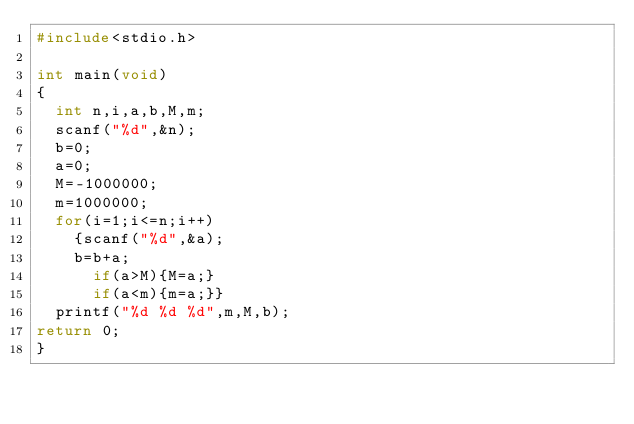<code> <loc_0><loc_0><loc_500><loc_500><_C_>#include<stdio.h>

int main(void)
{
	int n,i,a,b,M,m;
	scanf("%d",&n);
	b=0;
	a=0;
	M=-1000000;
	m=1000000;
	for(i=1;i<=n;i++)
		{scanf("%d",&a);
		b=b+a;
			if(a>M){M=a;}
			if(a<m){m=a;}}
	printf("%d %d %d",m,M,b);
return 0;
}
</code> 